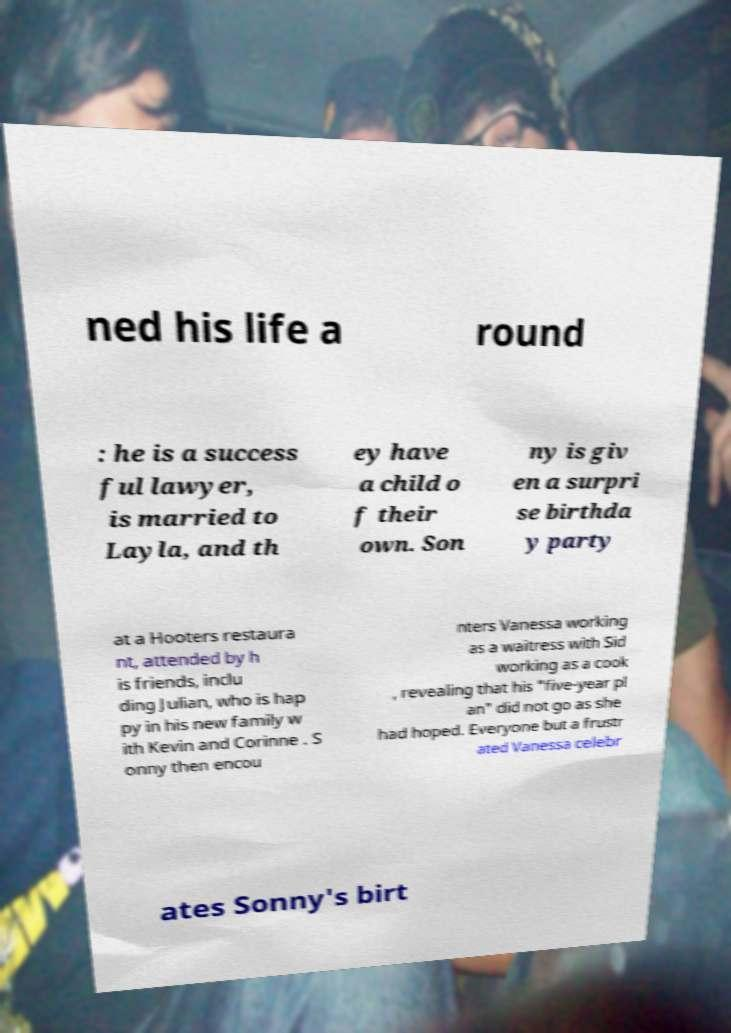Can you accurately transcribe the text from the provided image for me? ned his life a round : he is a success ful lawyer, is married to Layla, and th ey have a child o f their own. Son ny is giv en a surpri se birthda y party at a Hooters restaura nt, attended by h is friends, inclu ding Julian, who is hap py in his new family w ith Kevin and Corinne . S onny then encou nters Vanessa working as a waitress with Sid working as a cook , revealing that his "five-year pl an" did not go as she had hoped. Everyone but a frustr ated Vanessa celebr ates Sonny's birt 